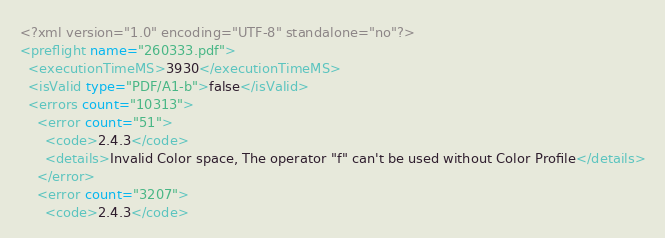<code> <loc_0><loc_0><loc_500><loc_500><_XML_><?xml version="1.0" encoding="UTF-8" standalone="no"?>
<preflight name="260333.pdf">
  <executionTimeMS>3930</executionTimeMS>
  <isValid type="PDF/A1-b">false</isValid>
  <errors count="10313">
    <error count="51">
      <code>2.4.3</code>
      <details>Invalid Color space, The operator "f" can't be used without Color Profile</details>
    </error>
    <error count="3207">
      <code>2.4.3</code></code> 